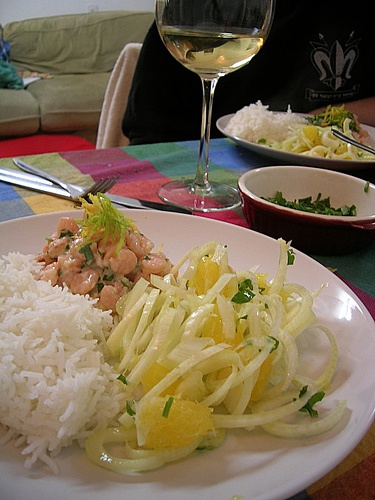Describe the objects in this image and their specific colors. I can see dining table in darkgray, tan, gray, and olive tones, people in darkgray, black, maroon, and gray tones, couch in darkgray, gray, and maroon tones, wine glass in darkgray, black, gray, tan, and brown tones, and bowl in darkgray, black, and gray tones in this image. 